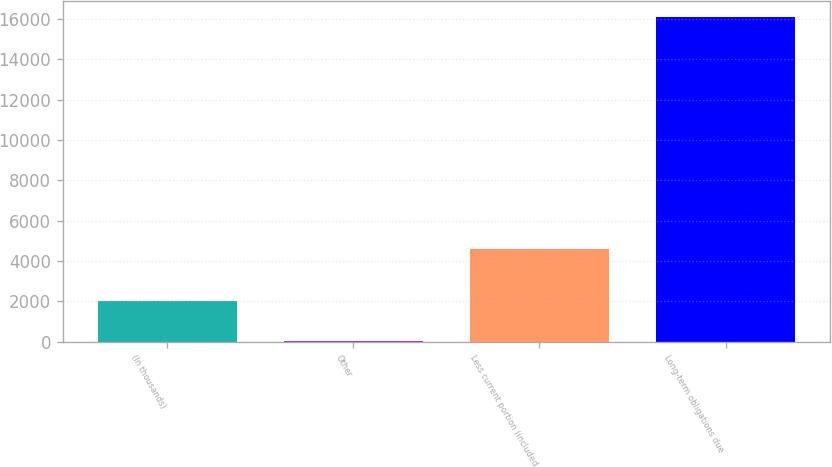<chart> <loc_0><loc_0><loc_500><loc_500><bar_chart><fcel>(In thousands)<fcel>Other<fcel>Less current portion (included<fcel>Long-term obligations due<nl><fcel>2004<fcel>51<fcel>4576<fcel>16106<nl></chart> 